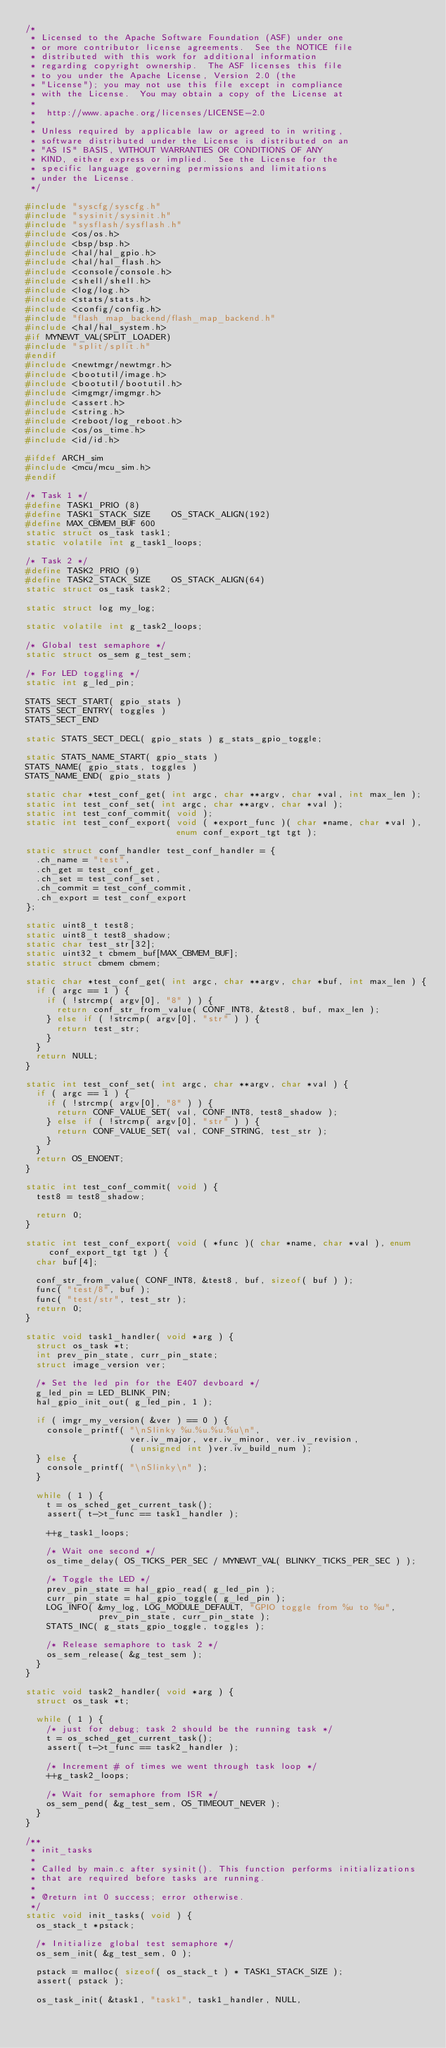Convert code to text. <code><loc_0><loc_0><loc_500><loc_500><_C_>/*
 * Licensed to the Apache Software Foundation (ASF) under one
 * or more contributor license agreements.  See the NOTICE file
 * distributed with this work for additional information
 * regarding copyright ownership.  The ASF licenses this file
 * to you under the Apache License, Version 2.0 (the
 * "License"); you may not use this file except in compliance
 * with the License.  You may obtain a copy of the License at
 *
 *  http://www.apache.org/licenses/LICENSE-2.0
 *
 * Unless required by applicable law or agreed to in writing,
 * software distributed under the License is distributed on an
 * "AS IS" BASIS, WITHOUT WARRANTIES OR CONDITIONS OF ANY
 * KIND, either express or implied.  See the License for the
 * specific language governing permissions and limitations
 * under the License.
 */

#include "syscfg/syscfg.h"
#include "sysinit/sysinit.h"
#include "sysflash/sysflash.h"
#include <os/os.h>
#include <bsp/bsp.h>
#include <hal/hal_gpio.h>
#include <hal/hal_flash.h>
#include <console/console.h>
#include <shell/shell.h>
#include <log/log.h>
#include <stats/stats.h>
#include <config/config.h>
#include "flash_map_backend/flash_map_backend.h"
#include <hal/hal_system.h>
#if MYNEWT_VAL(SPLIT_LOADER)
#include "split/split.h"
#endif
#include <newtmgr/newtmgr.h>
#include <bootutil/image.h>
#include <bootutil/bootutil.h>
#include <imgmgr/imgmgr.h>
#include <assert.h>
#include <string.h>
#include <reboot/log_reboot.h>
#include <os/os_time.h>
#include <id/id.h>

#ifdef ARCH_sim
#include <mcu/mcu_sim.h>
#endif

/* Task 1 */
#define TASK1_PRIO (8)
#define TASK1_STACK_SIZE    OS_STACK_ALIGN(192)
#define MAX_CBMEM_BUF 600
static struct os_task task1;
static volatile int g_task1_loops;

/* Task 2 */
#define TASK2_PRIO (9)
#define TASK2_STACK_SIZE    OS_STACK_ALIGN(64)
static struct os_task task2;

static struct log my_log;

static volatile int g_task2_loops;

/* Global test semaphore */
static struct os_sem g_test_sem;

/* For LED toggling */
static int g_led_pin;

STATS_SECT_START( gpio_stats )
STATS_SECT_ENTRY( toggles )
STATS_SECT_END

static STATS_SECT_DECL( gpio_stats ) g_stats_gpio_toggle;

static STATS_NAME_START( gpio_stats )
STATS_NAME( gpio_stats, toggles )
STATS_NAME_END( gpio_stats )

static char *test_conf_get( int argc, char **argv, char *val, int max_len );
static int test_conf_set( int argc, char **argv, char *val );
static int test_conf_commit( void );
static int test_conf_export( void ( *export_func )( char *name, char *val ),
                             enum conf_export_tgt tgt );

static struct conf_handler test_conf_handler = {
  .ch_name = "test",
  .ch_get = test_conf_get,
  .ch_set = test_conf_set,
  .ch_commit = test_conf_commit,
  .ch_export = test_conf_export
};

static uint8_t test8;
static uint8_t test8_shadow;
static char test_str[32];
static uint32_t cbmem_buf[MAX_CBMEM_BUF];
static struct cbmem cbmem;

static char *test_conf_get( int argc, char **argv, char *buf, int max_len ) {
  if ( argc == 1 ) {
    if ( !strcmp( argv[0], "8" ) ) {
      return conf_str_from_value( CONF_INT8, &test8, buf, max_len );
    } else if ( !strcmp( argv[0], "str" ) ) {
      return test_str;
    }
  }
  return NULL;
}

static int test_conf_set( int argc, char **argv, char *val ) {
  if ( argc == 1 ) {
    if ( !strcmp( argv[0], "8" ) ) {
      return CONF_VALUE_SET( val, CONF_INT8, test8_shadow );
    } else if ( !strcmp( argv[0], "str" ) ) {
      return CONF_VALUE_SET( val, CONF_STRING, test_str );
    }
  }
  return OS_ENOENT;
}

static int test_conf_commit( void ) {
  test8 = test8_shadow;

  return 0;
}

static int test_conf_export( void ( *func )( char *name, char *val ), enum conf_export_tgt tgt ) {
  char buf[4];

  conf_str_from_value( CONF_INT8, &test8, buf, sizeof( buf ) );
  func( "test/8", buf );
  func( "test/str", test_str );
  return 0;
}

static void task1_handler( void *arg ) {
  struct os_task *t;
  int prev_pin_state, curr_pin_state;
  struct image_version ver;

  /* Set the led pin for the E407 devboard */
  g_led_pin = LED_BLINK_PIN;
  hal_gpio_init_out( g_led_pin, 1 );

  if ( imgr_my_version( &ver ) == 0 ) {
    console_printf( "\nSlinky %u.%u.%u.%u\n",
                    ver.iv_major, ver.iv_minor, ver.iv_revision,
                    ( unsigned int )ver.iv_build_num );
  } else {
    console_printf( "\nSlinky\n" );
  }

  while ( 1 ) {
    t = os_sched_get_current_task();
    assert( t->t_func == task1_handler );

    ++g_task1_loops;

    /* Wait one second */
    os_time_delay( OS_TICKS_PER_SEC / MYNEWT_VAL( BLINKY_TICKS_PER_SEC ) );

    /* Toggle the LED */
    prev_pin_state = hal_gpio_read( g_led_pin );
    curr_pin_state = hal_gpio_toggle( g_led_pin );
    LOG_INFO( &my_log, LOG_MODULE_DEFAULT, "GPIO toggle from %u to %u",
              prev_pin_state, curr_pin_state );
    STATS_INC( g_stats_gpio_toggle, toggles );

    /* Release semaphore to task 2 */
    os_sem_release( &g_test_sem );
  }
}

static void task2_handler( void *arg ) {
  struct os_task *t;

  while ( 1 ) {
    /* just for debug; task 2 should be the running task */
    t = os_sched_get_current_task();
    assert( t->t_func == task2_handler );

    /* Increment # of times we went through task loop */
    ++g_task2_loops;

    /* Wait for semaphore from ISR */
    os_sem_pend( &g_test_sem, OS_TIMEOUT_NEVER );
  }
}

/**
 * init_tasks
 *
 * Called by main.c after sysinit(). This function performs initializations
 * that are required before tasks are running.
 *
 * @return int 0 success; error otherwise.
 */
static void init_tasks( void ) {
  os_stack_t *pstack;

  /* Initialize global test semaphore */
  os_sem_init( &g_test_sem, 0 );

  pstack = malloc( sizeof( os_stack_t ) * TASK1_STACK_SIZE );
  assert( pstack );

  os_task_init( &task1, "task1", task1_handler, NULL,</code> 